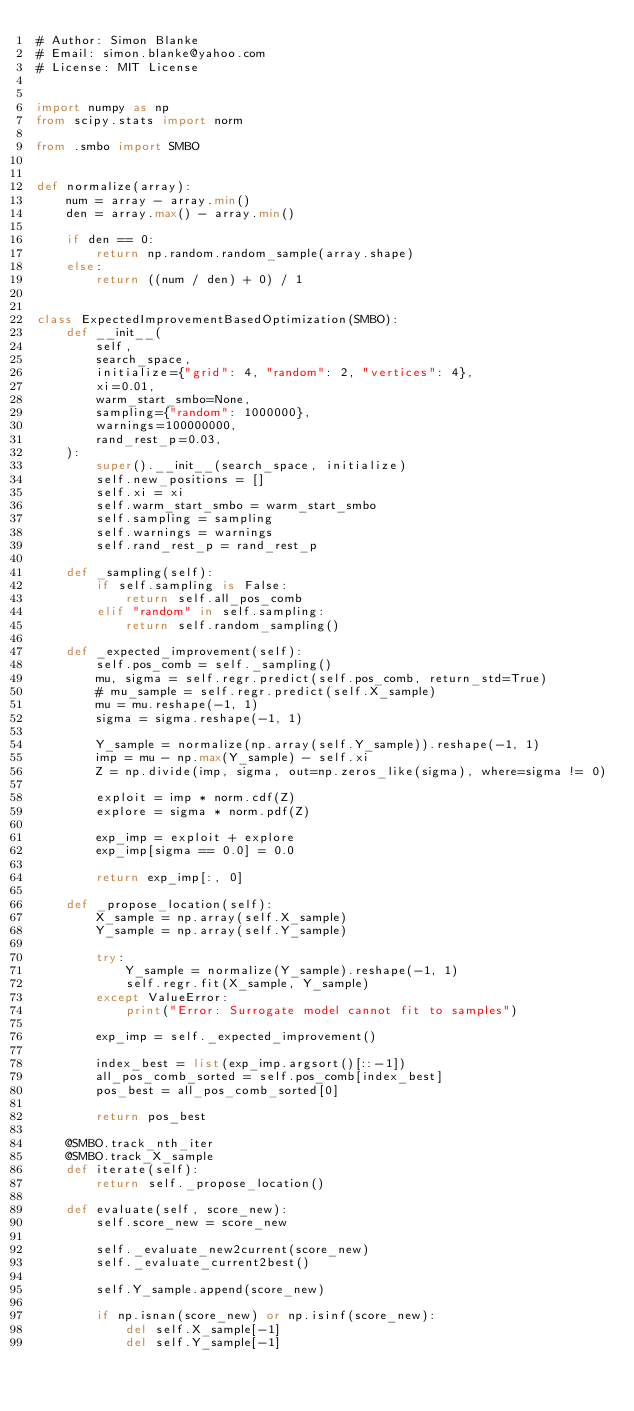Convert code to text. <code><loc_0><loc_0><loc_500><loc_500><_Python_># Author: Simon Blanke
# Email: simon.blanke@yahoo.com
# License: MIT License


import numpy as np
from scipy.stats import norm

from .smbo import SMBO


def normalize(array):
    num = array - array.min()
    den = array.max() - array.min()

    if den == 0:
        return np.random.random_sample(array.shape)
    else:
        return ((num / den) + 0) / 1


class ExpectedImprovementBasedOptimization(SMBO):
    def __init__(
        self,
        search_space,
        initialize={"grid": 4, "random": 2, "vertices": 4},
        xi=0.01,
        warm_start_smbo=None,
        sampling={"random": 1000000},
        warnings=100000000,
        rand_rest_p=0.03,
    ):
        super().__init__(search_space, initialize)
        self.new_positions = []
        self.xi = xi
        self.warm_start_smbo = warm_start_smbo
        self.sampling = sampling
        self.warnings = warnings
        self.rand_rest_p = rand_rest_p

    def _sampling(self):
        if self.sampling is False:
            return self.all_pos_comb
        elif "random" in self.sampling:
            return self.random_sampling()

    def _expected_improvement(self):
        self.pos_comb = self._sampling()
        mu, sigma = self.regr.predict(self.pos_comb, return_std=True)
        # mu_sample = self.regr.predict(self.X_sample)
        mu = mu.reshape(-1, 1)
        sigma = sigma.reshape(-1, 1)

        Y_sample = normalize(np.array(self.Y_sample)).reshape(-1, 1)
        imp = mu - np.max(Y_sample) - self.xi
        Z = np.divide(imp, sigma, out=np.zeros_like(sigma), where=sigma != 0)

        exploit = imp * norm.cdf(Z)
        explore = sigma * norm.pdf(Z)

        exp_imp = exploit + explore
        exp_imp[sigma == 0.0] = 0.0

        return exp_imp[:, 0]

    def _propose_location(self):
        X_sample = np.array(self.X_sample)
        Y_sample = np.array(self.Y_sample)

        try:
            Y_sample = normalize(Y_sample).reshape(-1, 1)
            self.regr.fit(X_sample, Y_sample)
        except ValueError:
            print("Error: Surrogate model cannot fit to samples")

        exp_imp = self._expected_improvement()

        index_best = list(exp_imp.argsort()[::-1])
        all_pos_comb_sorted = self.pos_comb[index_best]
        pos_best = all_pos_comb_sorted[0]

        return pos_best

    @SMBO.track_nth_iter
    @SMBO.track_X_sample
    def iterate(self):
        return self._propose_location()

    def evaluate(self, score_new):
        self.score_new = score_new

        self._evaluate_new2current(score_new)
        self._evaluate_current2best()

        self.Y_sample.append(score_new)

        if np.isnan(score_new) or np.isinf(score_new):
            del self.X_sample[-1]
            del self.Y_sample[-1]
</code> 